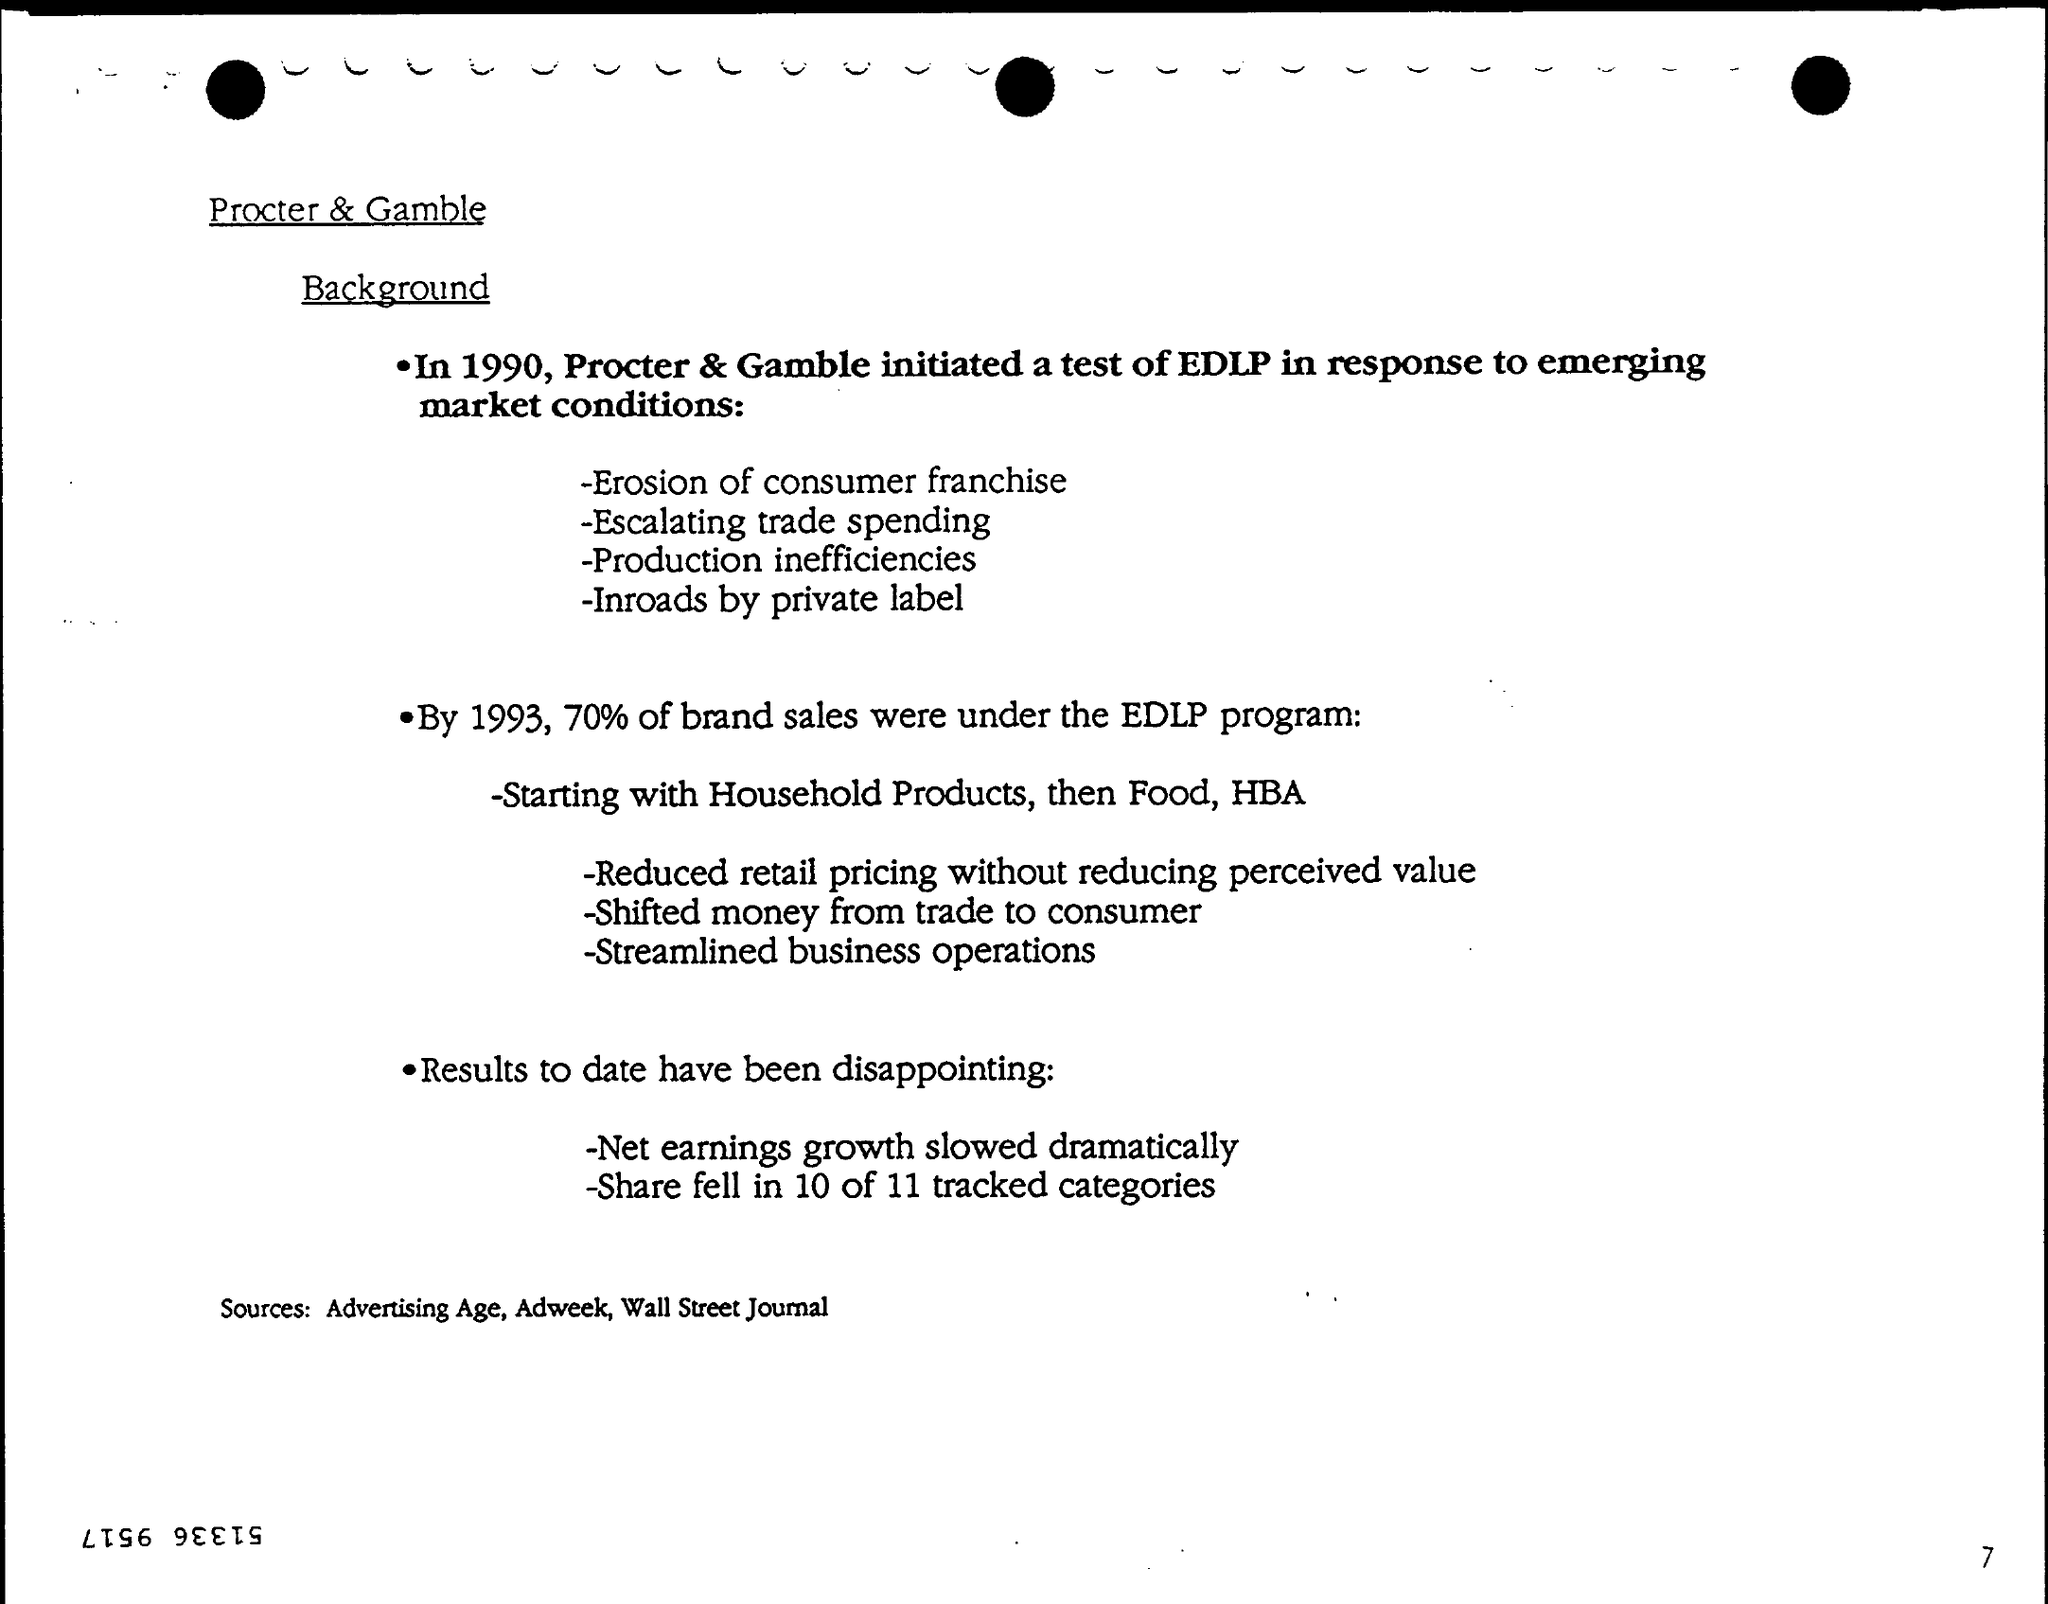Specify some key components in this picture. The page number is 7. The first title in the document is 'Procter & Gamble...' The document contains a second title, which is 'Background..'. 